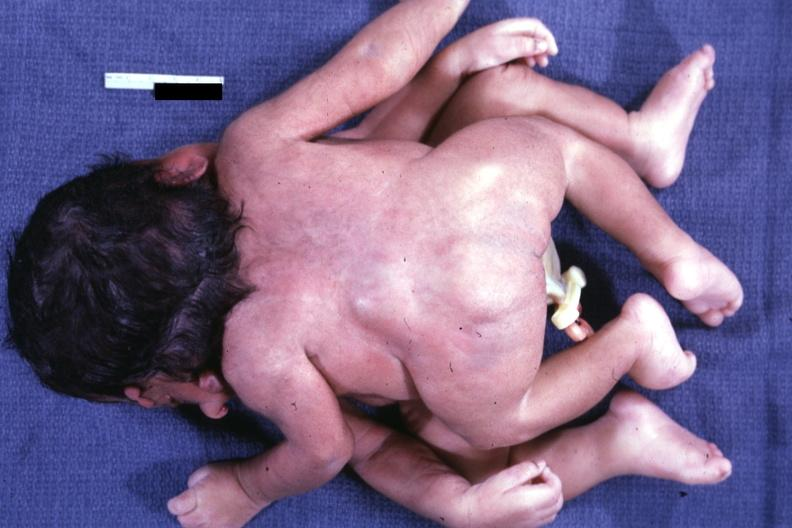does this image show twins joined at head facing each other?
Answer the question using a single word or phrase. Yes 